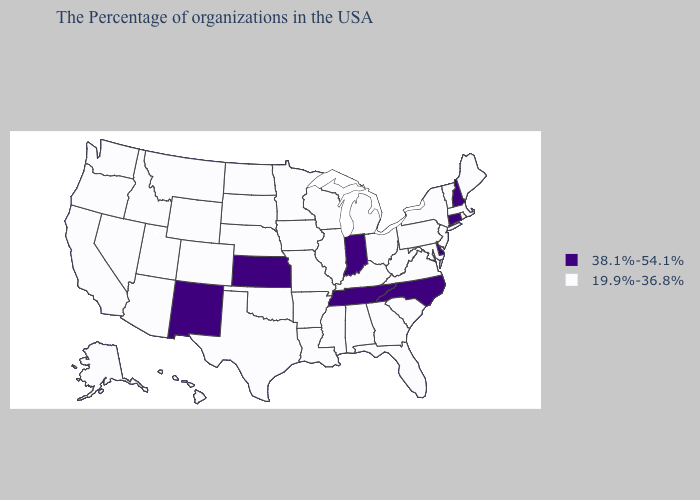Name the states that have a value in the range 38.1%-54.1%?
Answer briefly. New Hampshire, Connecticut, Delaware, North Carolina, Indiana, Tennessee, Kansas, New Mexico. Does Washington have the same value as Florida?
Answer briefly. Yes. Does Virginia have the lowest value in the USA?
Concise answer only. Yes. Name the states that have a value in the range 38.1%-54.1%?
Keep it brief. New Hampshire, Connecticut, Delaware, North Carolina, Indiana, Tennessee, Kansas, New Mexico. Does Kansas have the highest value in the USA?
Concise answer only. Yes. Among the states that border Missouri , does Kansas have the lowest value?
Short answer required. No. Does the first symbol in the legend represent the smallest category?
Quick response, please. No. What is the value of Kansas?
Write a very short answer. 38.1%-54.1%. Name the states that have a value in the range 19.9%-36.8%?
Be succinct. Maine, Massachusetts, Rhode Island, Vermont, New York, New Jersey, Maryland, Pennsylvania, Virginia, South Carolina, West Virginia, Ohio, Florida, Georgia, Michigan, Kentucky, Alabama, Wisconsin, Illinois, Mississippi, Louisiana, Missouri, Arkansas, Minnesota, Iowa, Nebraska, Oklahoma, Texas, South Dakota, North Dakota, Wyoming, Colorado, Utah, Montana, Arizona, Idaho, Nevada, California, Washington, Oregon, Alaska, Hawaii. Name the states that have a value in the range 38.1%-54.1%?
Quick response, please. New Hampshire, Connecticut, Delaware, North Carolina, Indiana, Tennessee, Kansas, New Mexico. Among the states that border Colorado , which have the highest value?
Give a very brief answer. Kansas, New Mexico. Name the states that have a value in the range 38.1%-54.1%?
Give a very brief answer. New Hampshire, Connecticut, Delaware, North Carolina, Indiana, Tennessee, Kansas, New Mexico. What is the value of Georgia?
Concise answer only. 19.9%-36.8%. 